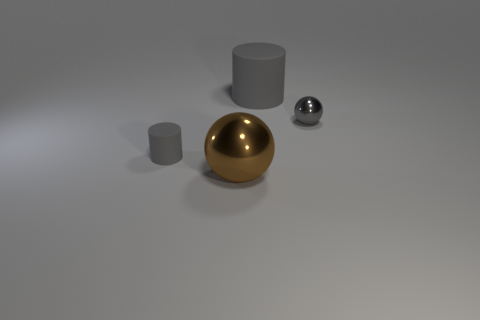What is the material of the big cylinder that is the same color as the small matte cylinder?
Make the answer very short. Rubber. What number of metal objects are the same color as the big rubber cylinder?
Provide a short and direct response. 1. Is there any other thing that is the same color as the tiny rubber cylinder?
Your response must be concise. Yes. Do the small rubber cylinder and the tiny shiny ball have the same color?
Your response must be concise. Yes. Are there fewer brown balls than matte cylinders?
Give a very brief answer. Yes. There is a large rubber object; are there any brown things on the left side of it?
Ensure brevity in your answer.  Yes. Does the brown thing have the same material as the gray ball?
Make the answer very short. Yes. What color is the other object that is the same shape as the tiny shiny object?
Make the answer very short. Brown. There is a matte cylinder that is on the right side of the small gray cylinder; is its color the same as the tiny cylinder?
Offer a very short reply. Yes. The tiny matte object that is the same color as the small sphere is what shape?
Your answer should be compact. Cylinder. 